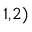Convert formula to latex. <formula><loc_0><loc_0><loc_500><loc_500>^ { 1 , 2 ) }</formula> 